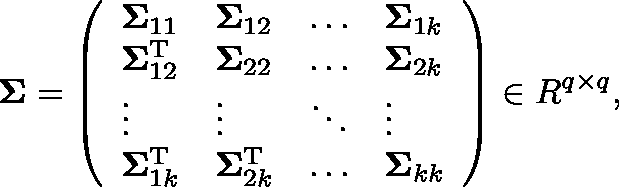<formula> <loc_0><loc_0><loc_500><loc_500>\Sigma = \left ( \begin{array} { l l l l } { \Sigma _ { 1 1 } } & { \Sigma _ { 1 2 } } & { \dots } & { \Sigma _ { 1 k } } \\ { \Sigma _ { 1 2 } ^ { T } } & { \Sigma _ { 2 2 } } & { \dots } & { \Sigma _ { 2 k } } \\ { \vdots } & { \vdots } & { \ddots } & { \vdots } \\ { \Sigma _ { 1 k } ^ { T } } & { \Sigma _ { 2 k } ^ { T } } & { \dots } & { \Sigma _ { k k } } \end{array} \right ) \in \mathbb { R } ^ { q \times q } ,</formula> 